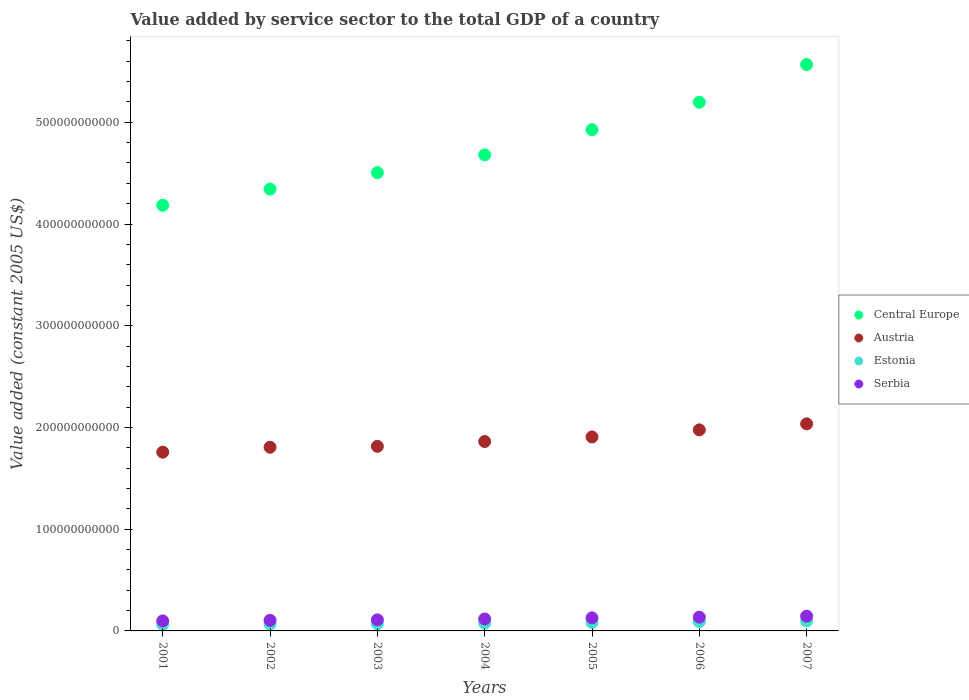How many different coloured dotlines are there?
Give a very brief answer. 4. What is the value added by service sector in Austria in 2006?
Keep it short and to the point. 1.98e+11. Across all years, what is the maximum value added by service sector in Serbia?
Keep it short and to the point. 1.45e+1. Across all years, what is the minimum value added by service sector in Estonia?
Give a very brief answer. 6.33e+09. What is the total value added by service sector in Central Europe in the graph?
Give a very brief answer. 3.34e+12. What is the difference between the value added by service sector in Estonia in 2001 and that in 2006?
Your response must be concise. -2.82e+09. What is the difference between the value added by service sector in Serbia in 2002 and the value added by service sector in Central Europe in 2007?
Provide a succinct answer. -5.46e+11. What is the average value added by service sector in Estonia per year?
Provide a short and direct response. 7.84e+09. In the year 2004, what is the difference between the value added by service sector in Serbia and value added by service sector in Estonia?
Provide a short and direct response. 4.15e+09. In how many years, is the value added by service sector in Serbia greater than 400000000000 US$?
Ensure brevity in your answer.  0. What is the ratio of the value added by service sector in Estonia in 2005 to that in 2007?
Provide a succinct answer. 0.85. Is the value added by service sector in Central Europe in 2004 less than that in 2007?
Offer a terse response. Yes. What is the difference between the highest and the second highest value added by service sector in Austria?
Your answer should be compact. 5.94e+09. What is the difference between the highest and the lowest value added by service sector in Austria?
Provide a short and direct response. 2.78e+1. Is it the case that in every year, the sum of the value added by service sector in Austria and value added by service sector in Serbia  is greater than the sum of value added by service sector in Central Europe and value added by service sector in Estonia?
Offer a terse response. Yes. How many dotlines are there?
Your answer should be compact. 4. What is the difference between two consecutive major ticks on the Y-axis?
Ensure brevity in your answer.  1.00e+11. Does the graph contain any zero values?
Give a very brief answer. No. Does the graph contain grids?
Your answer should be compact. No. Where does the legend appear in the graph?
Provide a succinct answer. Center right. How are the legend labels stacked?
Provide a succinct answer. Vertical. What is the title of the graph?
Offer a terse response. Value added by service sector to the total GDP of a country. Does "Bolivia" appear as one of the legend labels in the graph?
Provide a succinct answer. No. What is the label or title of the X-axis?
Your answer should be very brief. Years. What is the label or title of the Y-axis?
Give a very brief answer. Value added (constant 2005 US$). What is the Value added (constant 2005 US$) of Central Europe in 2001?
Keep it short and to the point. 4.18e+11. What is the Value added (constant 2005 US$) in Austria in 2001?
Your answer should be compact. 1.76e+11. What is the Value added (constant 2005 US$) in Estonia in 2001?
Provide a short and direct response. 6.33e+09. What is the Value added (constant 2005 US$) of Serbia in 2001?
Your answer should be very brief. 9.84e+09. What is the Value added (constant 2005 US$) of Central Europe in 2002?
Your answer should be compact. 4.34e+11. What is the Value added (constant 2005 US$) in Austria in 2002?
Provide a succinct answer. 1.81e+11. What is the Value added (constant 2005 US$) of Estonia in 2002?
Ensure brevity in your answer.  6.65e+09. What is the Value added (constant 2005 US$) of Serbia in 2002?
Offer a terse response. 1.04e+1. What is the Value added (constant 2005 US$) of Central Europe in 2003?
Provide a short and direct response. 4.50e+11. What is the Value added (constant 2005 US$) in Austria in 2003?
Your answer should be very brief. 1.81e+11. What is the Value added (constant 2005 US$) of Estonia in 2003?
Offer a terse response. 7.11e+09. What is the Value added (constant 2005 US$) in Serbia in 2003?
Your response must be concise. 1.09e+1. What is the Value added (constant 2005 US$) in Central Europe in 2004?
Make the answer very short. 4.68e+11. What is the Value added (constant 2005 US$) in Austria in 2004?
Offer a very short reply. 1.86e+11. What is the Value added (constant 2005 US$) in Estonia in 2004?
Offer a terse response. 7.62e+09. What is the Value added (constant 2005 US$) in Serbia in 2004?
Your answer should be very brief. 1.18e+1. What is the Value added (constant 2005 US$) in Central Europe in 2005?
Provide a short and direct response. 4.93e+11. What is the Value added (constant 2005 US$) of Austria in 2005?
Make the answer very short. 1.91e+11. What is the Value added (constant 2005 US$) in Estonia in 2005?
Make the answer very short. 8.28e+09. What is the Value added (constant 2005 US$) in Serbia in 2005?
Your answer should be compact. 1.29e+1. What is the Value added (constant 2005 US$) of Central Europe in 2006?
Your answer should be compact. 5.20e+11. What is the Value added (constant 2005 US$) in Austria in 2006?
Your answer should be very brief. 1.98e+11. What is the Value added (constant 2005 US$) in Estonia in 2006?
Give a very brief answer. 9.14e+09. What is the Value added (constant 2005 US$) of Serbia in 2006?
Provide a succinct answer. 1.35e+1. What is the Value added (constant 2005 US$) of Central Europe in 2007?
Your answer should be compact. 5.57e+11. What is the Value added (constant 2005 US$) in Austria in 2007?
Ensure brevity in your answer.  2.04e+11. What is the Value added (constant 2005 US$) of Estonia in 2007?
Keep it short and to the point. 9.79e+09. What is the Value added (constant 2005 US$) in Serbia in 2007?
Your answer should be very brief. 1.45e+1. Across all years, what is the maximum Value added (constant 2005 US$) in Central Europe?
Offer a very short reply. 5.57e+11. Across all years, what is the maximum Value added (constant 2005 US$) in Austria?
Offer a very short reply. 2.04e+11. Across all years, what is the maximum Value added (constant 2005 US$) of Estonia?
Make the answer very short. 9.79e+09. Across all years, what is the maximum Value added (constant 2005 US$) of Serbia?
Your answer should be compact. 1.45e+1. Across all years, what is the minimum Value added (constant 2005 US$) of Central Europe?
Make the answer very short. 4.18e+11. Across all years, what is the minimum Value added (constant 2005 US$) in Austria?
Your response must be concise. 1.76e+11. Across all years, what is the minimum Value added (constant 2005 US$) of Estonia?
Your answer should be very brief. 6.33e+09. Across all years, what is the minimum Value added (constant 2005 US$) of Serbia?
Keep it short and to the point. 9.84e+09. What is the total Value added (constant 2005 US$) of Central Europe in the graph?
Ensure brevity in your answer.  3.34e+12. What is the total Value added (constant 2005 US$) of Austria in the graph?
Provide a short and direct response. 1.32e+12. What is the total Value added (constant 2005 US$) in Estonia in the graph?
Give a very brief answer. 5.49e+1. What is the total Value added (constant 2005 US$) in Serbia in the graph?
Provide a short and direct response. 8.38e+1. What is the difference between the Value added (constant 2005 US$) of Central Europe in 2001 and that in 2002?
Give a very brief answer. -1.59e+1. What is the difference between the Value added (constant 2005 US$) in Austria in 2001 and that in 2002?
Your answer should be very brief. -4.82e+09. What is the difference between the Value added (constant 2005 US$) of Estonia in 2001 and that in 2002?
Provide a short and direct response. -3.25e+08. What is the difference between the Value added (constant 2005 US$) of Serbia in 2001 and that in 2002?
Give a very brief answer. -5.59e+08. What is the difference between the Value added (constant 2005 US$) of Central Europe in 2001 and that in 2003?
Keep it short and to the point. -3.21e+1. What is the difference between the Value added (constant 2005 US$) of Austria in 2001 and that in 2003?
Offer a terse response. -5.73e+09. What is the difference between the Value added (constant 2005 US$) of Estonia in 2001 and that in 2003?
Provide a short and direct response. -7.81e+08. What is the difference between the Value added (constant 2005 US$) of Serbia in 2001 and that in 2003?
Your answer should be very brief. -1.05e+09. What is the difference between the Value added (constant 2005 US$) in Central Europe in 2001 and that in 2004?
Your answer should be compact. -4.96e+1. What is the difference between the Value added (constant 2005 US$) in Austria in 2001 and that in 2004?
Your answer should be compact. -1.05e+1. What is the difference between the Value added (constant 2005 US$) in Estonia in 2001 and that in 2004?
Your response must be concise. -1.29e+09. What is the difference between the Value added (constant 2005 US$) in Serbia in 2001 and that in 2004?
Your answer should be compact. -1.93e+09. What is the difference between the Value added (constant 2005 US$) in Central Europe in 2001 and that in 2005?
Offer a very short reply. -7.43e+1. What is the difference between the Value added (constant 2005 US$) of Austria in 2001 and that in 2005?
Your answer should be compact. -1.50e+1. What is the difference between the Value added (constant 2005 US$) of Estonia in 2001 and that in 2005?
Make the answer very short. -1.95e+09. What is the difference between the Value added (constant 2005 US$) of Serbia in 2001 and that in 2005?
Your response must be concise. -3.02e+09. What is the difference between the Value added (constant 2005 US$) of Central Europe in 2001 and that in 2006?
Make the answer very short. -1.01e+11. What is the difference between the Value added (constant 2005 US$) of Austria in 2001 and that in 2006?
Your answer should be very brief. -2.19e+1. What is the difference between the Value added (constant 2005 US$) in Estonia in 2001 and that in 2006?
Offer a terse response. -2.82e+09. What is the difference between the Value added (constant 2005 US$) in Serbia in 2001 and that in 2006?
Make the answer very short. -3.66e+09. What is the difference between the Value added (constant 2005 US$) of Central Europe in 2001 and that in 2007?
Ensure brevity in your answer.  -1.38e+11. What is the difference between the Value added (constant 2005 US$) of Austria in 2001 and that in 2007?
Offer a very short reply. -2.78e+1. What is the difference between the Value added (constant 2005 US$) in Estonia in 2001 and that in 2007?
Offer a very short reply. -3.46e+09. What is the difference between the Value added (constant 2005 US$) in Serbia in 2001 and that in 2007?
Provide a succinct answer. -4.68e+09. What is the difference between the Value added (constant 2005 US$) of Central Europe in 2002 and that in 2003?
Provide a short and direct response. -1.62e+1. What is the difference between the Value added (constant 2005 US$) in Austria in 2002 and that in 2003?
Make the answer very short. -9.14e+08. What is the difference between the Value added (constant 2005 US$) of Estonia in 2002 and that in 2003?
Keep it short and to the point. -4.56e+08. What is the difference between the Value added (constant 2005 US$) in Serbia in 2002 and that in 2003?
Provide a succinct answer. -4.90e+08. What is the difference between the Value added (constant 2005 US$) of Central Europe in 2002 and that in 2004?
Offer a very short reply. -3.37e+1. What is the difference between the Value added (constant 2005 US$) in Austria in 2002 and that in 2004?
Offer a very short reply. -5.64e+09. What is the difference between the Value added (constant 2005 US$) of Estonia in 2002 and that in 2004?
Your answer should be compact. -9.63e+08. What is the difference between the Value added (constant 2005 US$) of Serbia in 2002 and that in 2004?
Provide a short and direct response. -1.37e+09. What is the difference between the Value added (constant 2005 US$) in Central Europe in 2002 and that in 2005?
Your answer should be compact. -5.84e+1. What is the difference between the Value added (constant 2005 US$) of Austria in 2002 and that in 2005?
Keep it short and to the point. -1.01e+1. What is the difference between the Value added (constant 2005 US$) of Estonia in 2002 and that in 2005?
Make the answer very short. -1.62e+09. What is the difference between the Value added (constant 2005 US$) of Serbia in 2002 and that in 2005?
Your response must be concise. -2.46e+09. What is the difference between the Value added (constant 2005 US$) of Central Europe in 2002 and that in 2006?
Provide a succinct answer. -8.54e+1. What is the difference between the Value added (constant 2005 US$) in Austria in 2002 and that in 2006?
Provide a short and direct response. -1.71e+1. What is the difference between the Value added (constant 2005 US$) of Estonia in 2002 and that in 2006?
Offer a terse response. -2.49e+09. What is the difference between the Value added (constant 2005 US$) of Serbia in 2002 and that in 2006?
Ensure brevity in your answer.  -3.11e+09. What is the difference between the Value added (constant 2005 US$) in Central Europe in 2002 and that in 2007?
Your answer should be compact. -1.22e+11. What is the difference between the Value added (constant 2005 US$) of Austria in 2002 and that in 2007?
Keep it short and to the point. -2.30e+1. What is the difference between the Value added (constant 2005 US$) of Estonia in 2002 and that in 2007?
Offer a very short reply. -3.13e+09. What is the difference between the Value added (constant 2005 US$) of Serbia in 2002 and that in 2007?
Your answer should be very brief. -4.13e+09. What is the difference between the Value added (constant 2005 US$) of Central Europe in 2003 and that in 2004?
Offer a very short reply. -1.75e+1. What is the difference between the Value added (constant 2005 US$) in Austria in 2003 and that in 2004?
Make the answer very short. -4.73e+09. What is the difference between the Value added (constant 2005 US$) in Estonia in 2003 and that in 2004?
Ensure brevity in your answer.  -5.08e+08. What is the difference between the Value added (constant 2005 US$) of Serbia in 2003 and that in 2004?
Your answer should be very brief. -8.79e+08. What is the difference between the Value added (constant 2005 US$) in Central Europe in 2003 and that in 2005?
Make the answer very short. -4.22e+1. What is the difference between the Value added (constant 2005 US$) in Austria in 2003 and that in 2005?
Ensure brevity in your answer.  -9.23e+09. What is the difference between the Value added (constant 2005 US$) in Estonia in 2003 and that in 2005?
Give a very brief answer. -1.17e+09. What is the difference between the Value added (constant 2005 US$) in Serbia in 2003 and that in 2005?
Keep it short and to the point. -1.97e+09. What is the difference between the Value added (constant 2005 US$) in Central Europe in 2003 and that in 2006?
Make the answer very short. -6.92e+1. What is the difference between the Value added (constant 2005 US$) in Austria in 2003 and that in 2006?
Offer a very short reply. -1.62e+1. What is the difference between the Value added (constant 2005 US$) of Estonia in 2003 and that in 2006?
Your answer should be very brief. -2.03e+09. What is the difference between the Value added (constant 2005 US$) in Serbia in 2003 and that in 2006?
Ensure brevity in your answer.  -2.61e+09. What is the difference between the Value added (constant 2005 US$) in Central Europe in 2003 and that in 2007?
Your response must be concise. -1.06e+11. What is the difference between the Value added (constant 2005 US$) of Austria in 2003 and that in 2007?
Provide a short and direct response. -2.21e+1. What is the difference between the Value added (constant 2005 US$) of Estonia in 2003 and that in 2007?
Your answer should be very brief. -2.68e+09. What is the difference between the Value added (constant 2005 US$) of Serbia in 2003 and that in 2007?
Provide a short and direct response. -3.64e+09. What is the difference between the Value added (constant 2005 US$) in Central Europe in 2004 and that in 2005?
Keep it short and to the point. -2.47e+1. What is the difference between the Value added (constant 2005 US$) in Austria in 2004 and that in 2005?
Your response must be concise. -4.50e+09. What is the difference between the Value added (constant 2005 US$) in Estonia in 2004 and that in 2005?
Offer a very short reply. -6.59e+08. What is the difference between the Value added (constant 2005 US$) in Serbia in 2004 and that in 2005?
Keep it short and to the point. -1.10e+09. What is the difference between the Value added (constant 2005 US$) of Central Europe in 2004 and that in 2006?
Offer a very short reply. -5.17e+1. What is the difference between the Value added (constant 2005 US$) of Austria in 2004 and that in 2006?
Your answer should be very brief. -1.14e+1. What is the difference between the Value added (constant 2005 US$) in Estonia in 2004 and that in 2006?
Offer a very short reply. -1.53e+09. What is the difference between the Value added (constant 2005 US$) in Serbia in 2004 and that in 2006?
Ensure brevity in your answer.  -1.74e+09. What is the difference between the Value added (constant 2005 US$) of Central Europe in 2004 and that in 2007?
Your answer should be very brief. -8.88e+1. What is the difference between the Value added (constant 2005 US$) in Austria in 2004 and that in 2007?
Give a very brief answer. -1.74e+1. What is the difference between the Value added (constant 2005 US$) of Estonia in 2004 and that in 2007?
Provide a succinct answer. -2.17e+09. What is the difference between the Value added (constant 2005 US$) of Serbia in 2004 and that in 2007?
Provide a short and direct response. -2.76e+09. What is the difference between the Value added (constant 2005 US$) of Central Europe in 2005 and that in 2006?
Offer a very short reply. -2.70e+1. What is the difference between the Value added (constant 2005 US$) of Austria in 2005 and that in 2006?
Your response must be concise. -6.94e+09. What is the difference between the Value added (constant 2005 US$) of Estonia in 2005 and that in 2006?
Offer a very short reply. -8.69e+08. What is the difference between the Value added (constant 2005 US$) in Serbia in 2005 and that in 2006?
Give a very brief answer. -6.40e+08. What is the difference between the Value added (constant 2005 US$) in Central Europe in 2005 and that in 2007?
Provide a succinct answer. -6.40e+1. What is the difference between the Value added (constant 2005 US$) in Austria in 2005 and that in 2007?
Make the answer very short. -1.29e+1. What is the difference between the Value added (constant 2005 US$) in Estonia in 2005 and that in 2007?
Your response must be concise. -1.51e+09. What is the difference between the Value added (constant 2005 US$) in Serbia in 2005 and that in 2007?
Provide a succinct answer. -1.66e+09. What is the difference between the Value added (constant 2005 US$) in Central Europe in 2006 and that in 2007?
Ensure brevity in your answer.  -3.70e+1. What is the difference between the Value added (constant 2005 US$) in Austria in 2006 and that in 2007?
Offer a very short reply. -5.94e+09. What is the difference between the Value added (constant 2005 US$) of Estonia in 2006 and that in 2007?
Your answer should be very brief. -6.43e+08. What is the difference between the Value added (constant 2005 US$) in Serbia in 2006 and that in 2007?
Ensure brevity in your answer.  -1.02e+09. What is the difference between the Value added (constant 2005 US$) in Central Europe in 2001 and the Value added (constant 2005 US$) in Austria in 2002?
Offer a very short reply. 2.38e+11. What is the difference between the Value added (constant 2005 US$) in Central Europe in 2001 and the Value added (constant 2005 US$) in Estonia in 2002?
Your answer should be compact. 4.12e+11. What is the difference between the Value added (constant 2005 US$) of Central Europe in 2001 and the Value added (constant 2005 US$) of Serbia in 2002?
Your response must be concise. 4.08e+11. What is the difference between the Value added (constant 2005 US$) in Austria in 2001 and the Value added (constant 2005 US$) in Estonia in 2002?
Your response must be concise. 1.69e+11. What is the difference between the Value added (constant 2005 US$) of Austria in 2001 and the Value added (constant 2005 US$) of Serbia in 2002?
Provide a short and direct response. 1.65e+11. What is the difference between the Value added (constant 2005 US$) in Estonia in 2001 and the Value added (constant 2005 US$) in Serbia in 2002?
Your answer should be very brief. -4.07e+09. What is the difference between the Value added (constant 2005 US$) of Central Europe in 2001 and the Value added (constant 2005 US$) of Austria in 2003?
Offer a very short reply. 2.37e+11. What is the difference between the Value added (constant 2005 US$) in Central Europe in 2001 and the Value added (constant 2005 US$) in Estonia in 2003?
Your response must be concise. 4.11e+11. What is the difference between the Value added (constant 2005 US$) of Central Europe in 2001 and the Value added (constant 2005 US$) of Serbia in 2003?
Provide a succinct answer. 4.08e+11. What is the difference between the Value added (constant 2005 US$) of Austria in 2001 and the Value added (constant 2005 US$) of Estonia in 2003?
Provide a succinct answer. 1.69e+11. What is the difference between the Value added (constant 2005 US$) of Austria in 2001 and the Value added (constant 2005 US$) of Serbia in 2003?
Keep it short and to the point. 1.65e+11. What is the difference between the Value added (constant 2005 US$) in Estonia in 2001 and the Value added (constant 2005 US$) in Serbia in 2003?
Offer a terse response. -4.56e+09. What is the difference between the Value added (constant 2005 US$) of Central Europe in 2001 and the Value added (constant 2005 US$) of Austria in 2004?
Give a very brief answer. 2.32e+11. What is the difference between the Value added (constant 2005 US$) in Central Europe in 2001 and the Value added (constant 2005 US$) in Estonia in 2004?
Offer a terse response. 4.11e+11. What is the difference between the Value added (constant 2005 US$) in Central Europe in 2001 and the Value added (constant 2005 US$) in Serbia in 2004?
Your response must be concise. 4.07e+11. What is the difference between the Value added (constant 2005 US$) in Austria in 2001 and the Value added (constant 2005 US$) in Estonia in 2004?
Your answer should be very brief. 1.68e+11. What is the difference between the Value added (constant 2005 US$) of Austria in 2001 and the Value added (constant 2005 US$) of Serbia in 2004?
Ensure brevity in your answer.  1.64e+11. What is the difference between the Value added (constant 2005 US$) of Estonia in 2001 and the Value added (constant 2005 US$) of Serbia in 2004?
Provide a succinct answer. -5.44e+09. What is the difference between the Value added (constant 2005 US$) in Central Europe in 2001 and the Value added (constant 2005 US$) in Austria in 2005?
Offer a terse response. 2.28e+11. What is the difference between the Value added (constant 2005 US$) in Central Europe in 2001 and the Value added (constant 2005 US$) in Estonia in 2005?
Your response must be concise. 4.10e+11. What is the difference between the Value added (constant 2005 US$) of Central Europe in 2001 and the Value added (constant 2005 US$) of Serbia in 2005?
Your response must be concise. 4.06e+11. What is the difference between the Value added (constant 2005 US$) of Austria in 2001 and the Value added (constant 2005 US$) of Estonia in 2005?
Your response must be concise. 1.67e+11. What is the difference between the Value added (constant 2005 US$) in Austria in 2001 and the Value added (constant 2005 US$) in Serbia in 2005?
Provide a succinct answer. 1.63e+11. What is the difference between the Value added (constant 2005 US$) in Estonia in 2001 and the Value added (constant 2005 US$) in Serbia in 2005?
Make the answer very short. -6.54e+09. What is the difference between the Value added (constant 2005 US$) in Central Europe in 2001 and the Value added (constant 2005 US$) in Austria in 2006?
Offer a very short reply. 2.21e+11. What is the difference between the Value added (constant 2005 US$) in Central Europe in 2001 and the Value added (constant 2005 US$) in Estonia in 2006?
Your answer should be very brief. 4.09e+11. What is the difference between the Value added (constant 2005 US$) in Central Europe in 2001 and the Value added (constant 2005 US$) in Serbia in 2006?
Offer a terse response. 4.05e+11. What is the difference between the Value added (constant 2005 US$) in Austria in 2001 and the Value added (constant 2005 US$) in Estonia in 2006?
Your answer should be very brief. 1.67e+11. What is the difference between the Value added (constant 2005 US$) of Austria in 2001 and the Value added (constant 2005 US$) of Serbia in 2006?
Keep it short and to the point. 1.62e+11. What is the difference between the Value added (constant 2005 US$) in Estonia in 2001 and the Value added (constant 2005 US$) in Serbia in 2006?
Offer a very short reply. -7.18e+09. What is the difference between the Value added (constant 2005 US$) in Central Europe in 2001 and the Value added (constant 2005 US$) in Austria in 2007?
Provide a succinct answer. 2.15e+11. What is the difference between the Value added (constant 2005 US$) of Central Europe in 2001 and the Value added (constant 2005 US$) of Estonia in 2007?
Your response must be concise. 4.09e+11. What is the difference between the Value added (constant 2005 US$) in Central Europe in 2001 and the Value added (constant 2005 US$) in Serbia in 2007?
Offer a very short reply. 4.04e+11. What is the difference between the Value added (constant 2005 US$) in Austria in 2001 and the Value added (constant 2005 US$) in Estonia in 2007?
Keep it short and to the point. 1.66e+11. What is the difference between the Value added (constant 2005 US$) of Austria in 2001 and the Value added (constant 2005 US$) of Serbia in 2007?
Make the answer very short. 1.61e+11. What is the difference between the Value added (constant 2005 US$) in Estonia in 2001 and the Value added (constant 2005 US$) in Serbia in 2007?
Your answer should be compact. -8.20e+09. What is the difference between the Value added (constant 2005 US$) in Central Europe in 2002 and the Value added (constant 2005 US$) in Austria in 2003?
Make the answer very short. 2.53e+11. What is the difference between the Value added (constant 2005 US$) in Central Europe in 2002 and the Value added (constant 2005 US$) in Estonia in 2003?
Make the answer very short. 4.27e+11. What is the difference between the Value added (constant 2005 US$) in Central Europe in 2002 and the Value added (constant 2005 US$) in Serbia in 2003?
Offer a very short reply. 4.23e+11. What is the difference between the Value added (constant 2005 US$) of Austria in 2002 and the Value added (constant 2005 US$) of Estonia in 2003?
Make the answer very short. 1.73e+11. What is the difference between the Value added (constant 2005 US$) of Austria in 2002 and the Value added (constant 2005 US$) of Serbia in 2003?
Offer a very short reply. 1.70e+11. What is the difference between the Value added (constant 2005 US$) in Estonia in 2002 and the Value added (constant 2005 US$) in Serbia in 2003?
Make the answer very short. -4.24e+09. What is the difference between the Value added (constant 2005 US$) in Central Europe in 2002 and the Value added (constant 2005 US$) in Austria in 2004?
Make the answer very short. 2.48e+11. What is the difference between the Value added (constant 2005 US$) of Central Europe in 2002 and the Value added (constant 2005 US$) of Estonia in 2004?
Provide a succinct answer. 4.27e+11. What is the difference between the Value added (constant 2005 US$) in Central Europe in 2002 and the Value added (constant 2005 US$) in Serbia in 2004?
Your answer should be compact. 4.23e+11. What is the difference between the Value added (constant 2005 US$) of Austria in 2002 and the Value added (constant 2005 US$) of Estonia in 2004?
Your answer should be very brief. 1.73e+11. What is the difference between the Value added (constant 2005 US$) of Austria in 2002 and the Value added (constant 2005 US$) of Serbia in 2004?
Make the answer very short. 1.69e+11. What is the difference between the Value added (constant 2005 US$) in Estonia in 2002 and the Value added (constant 2005 US$) in Serbia in 2004?
Your answer should be compact. -5.12e+09. What is the difference between the Value added (constant 2005 US$) in Central Europe in 2002 and the Value added (constant 2005 US$) in Austria in 2005?
Provide a succinct answer. 2.44e+11. What is the difference between the Value added (constant 2005 US$) in Central Europe in 2002 and the Value added (constant 2005 US$) in Estonia in 2005?
Provide a short and direct response. 4.26e+11. What is the difference between the Value added (constant 2005 US$) of Central Europe in 2002 and the Value added (constant 2005 US$) of Serbia in 2005?
Ensure brevity in your answer.  4.21e+11. What is the difference between the Value added (constant 2005 US$) of Austria in 2002 and the Value added (constant 2005 US$) of Estonia in 2005?
Make the answer very short. 1.72e+11. What is the difference between the Value added (constant 2005 US$) of Austria in 2002 and the Value added (constant 2005 US$) of Serbia in 2005?
Offer a terse response. 1.68e+11. What is the difference between the Value added (constant 2005 US$) in Estonia in 2002 and the Value added (constant 2005 US$) in Serbia in 2005?
Ensure brevity in your answer.  -6.21e+09. What is the difference between the Value added (constant 2005 US$) in Central Europe in 2002 and the Value added (constant 2005 US$) in Austria in 2006?
Keep it short and to the point. 2.37e+11. What is the difference between the Value added (constant 2005 US$) in Central Europe in 2002 and the Value added (constant 2005 US$) in Estonia in 2006?
Your response must be concise. 4.25e+11. What is the difference between the Value added (constant 2005 US$) in Central Europe in 2002 and the Value added (constant 2005 US$) in Serbia in 2006?
Your response must be concise. 4.21e+11. What is the difference between the Value added (constant 2005 US$) in Austria in 2002 and the Value added (constant 2005 US$) in Estonia in 2006?
Provide a succinct answer. 1.71e+11. What is the difference between the Value added (constant 2005 US$) of Austria in 2002 and the Value added (constant 2005 US$) of Serbia in 2006?
Your answer should be compact. 1.67e+11. What is the difference between the Value added (constant 2005 US$) of Estonia in 2002 and the Value added (constant 2005 US$) of Serbia in 2006?
Your answer should be very brief. -6.85e+09. What is the difference between the Value added (constant 2005 US$) of Central Europe in 2002 and the Value added (constant 2005 US$) of Austria in 2007?
Provide a short and direct response. 2.31e+11. What is the difference between the Value added (constant 2005 US$) of Central Europe in 2002 and the Value added (constant 2005 US$) of Estonia in 2007?
Provide a short and direct response. 4.25e+11. What is the difference between the Value added (constant 2005 US$) in Central Europe in 2002 and the Value added (constant 2005 US$) in Serbia in 2007?
Give a very brief answer. 4.20e+11. What is the difference between the Value added (constant 2005 US$) of Austria in 2002 and the Value added (constant 2005 US$) of Estonia in 2007?
Offer a terse response. 1.71e+11. What is the difference between the Value added (constant 2005 US$) of Austria in 2002 and the Value added (constant 2005 US$) of Serbia in 2007?
Make the answer very short. 1.66e+11. What is the difference between the Value added (constant 2005 US$) of Estonia in 2002 and the Value added (constant 2005 US$) of Serbia in 2007?
Give a very brief answer. -7.87e+09. What is the difference between the Value added (constant 2005 US$) of Central Europe in 2003 and the Value added (constant 2005 US$) of Austria in 2004?
Provide a short and direct response. 2.64e+11. What is the difference between the Value added (constant 2005 US$) of Central Europe in 2003 and the Value added (constant 2005 US$) of Estonia in 2004?
Make the answer very short. 4.43e+11. What is the difference between the Value added (constant 2005 US$) in Central Europe in 2003 and the Value added (constant 2005 US$) in Serbia in 2004?
Ensure brevity in your answer.  4.39e+11. What is the difference between the Value added (constant 2005 US$) of Austria in 2003 and the Value added (constant 2005 US$) of Estonia in 2004?
Ensure brevity in your answer.  1.74e+11. What is the difference between the Value added (constant 2005 US$) in Austria in 2003 and the Value added (constant 2005 US$) in Serbia in 2004?
Your answer should be compact. 1.70e+11. What is the difference between the Value added (constant 2005 US$) in Estonia in 2003 and the Value added (constant 2005 US$) in Serbia in 2004?
Your response must be concise. -4.66e+09. What is the difference between the Value added (constant 2005 US$) in Central Europe in 2003 and the Value added (constant 2005 US$) in Austria in 2005?
Ensure brevity in your answer.  2.60e+11. What is the difference between the Value added (constant 2005 US$) of Central Europe in 2003 and the Value added (constant 2005 US$) of Estonia in 2005?
Make the answer very short. 4.42e+11. What is the difference between the Value added (constant 2005 US$) of Central Europe in 2003 and the Value added (constant 2005 US$) of Serbia in 2005?
Provide a short and direct response. 4.38e+11. What is the difference between the Value added (constant 2005 US$) in Austria in 2003 and the Value added (constant 2005 US$) in Estonia in 2005?
Give a very brief answer. 1.73e+11. What is the difference between the Value added (constant 2005 US$) of Austria in 2003 and the Value added (constant 2005 US$) of Serbia in 2005?
Provide a succinct answer. 1.69e+11. What is the difference between the Value added (constant 2005 US$) in Estonia in 2003 and the Value added (constant 2005 US$) in Serbia in 2005?
Your response must be concise. -5.76e+09. What is the difference between the Value added (constant 2005 US$) in Central Europe in 2003 and the Value added (constant 2005 US$) in Austria in 2006?
Ensure brevity in your answer.  2.53e+11. What is the difference between the Value added (constant 2005 US$) of Central Europe in 2003 and the Value added (constant 2005 US$) of Estonia in 2006?
Provide a succinct answer. 4.41e+11. What is the difference between the Value added (constant 2005 US$) of Central Europe in 2003 and the Value added (constant 2005 US$) of Serbia in 2006?
Offer a terse response. 4.37e+11. What is the difference between the Value added (constant 2005 US$) of Austria in 2003 and the Value added (constant 2005 US$) of Estonia in 2006?
Offer a terse response. 1.72e+11. What is the difference between the Value added (constant 2005 US$) in Austria in 2003 and the Value added (constant 2005 US$) in Serbia in 2006?
Ensure brevity in your answer.  1.68e+11. What is the difference between the Value added (constant 2005 US$) in Estonia in 2003 and the Value added (constant 2005 US$) in Serbia in 2006?
Offer a terse response. -6.40e+09. What is the difference between the Value added (constant 2005 US$) of Central Europe in 2003 and the Value added (constant 2005 US$) of Austria in 2007?
Your answer should be very brief. 2.47e+11. What is the difference between the Value added (constant 2005 US$) of Central Europe in 2003 and the Value added (constant 2005 US$) of Estonia in 2007?
Provide a succinct answer. 4.41e+11. What is the difference between the Value added (constant 2005 US$) in Central Europe in 2003 and the Value added (constant 2005 US$) in Serbia in 2007?
Your response must be concise. 4.36e+11. What is the difference between the Value added (constant 2005 US$) of Austria in 2003 and the Value added (constant 2005 US$) of Estonia in 2007?
Your response must be concise. 1.72e+11. What is the difference between the Value added (constant 2005 US$) of Austria in 2003 and the Value added (constant 2005 US$) of Serbia in 2007?
Offer a very short reply. 1.67e+11. What is the difference between the Value added (constant 2005 US$) of Estonia in 2003 and the Value added (constant 2005 US$) of Serbia in 2007?
Offer a terse response. -7.42e+09. What is the difference between the Value added (constant 2005 US$) in Central Europe in 2004 and the Value added (constant 2005 US$) in Austria in 2005?
Offer a terse response. 2.77e+11. What is the difference between the Value added (constant 2005 US$) in Central Europe in 2004 and the Value added (constant 2005 US$) in Estonia in 2005?
Ensure brevity in your answer.  4.60e+11. What is the difference between the Value added (constant 2005 US$) of Central Europe in 2004 and the Value added (constant 2005 US$) of Serbia in 2005?
Offer a terse response. 4.55e+11. What is the difference between the Value added (constant 2005 US$) in Austria in 2004 and the Value added (constant 2005 US$) in Estonia in 2005?
Make the answer very short. 1.78e+11. What is the difference between the Value added (constant 2005 US$) in Austria in 2004 and the Value added (constant 2005 US$) in Serbia in 2005?
Your answer should be very brief. 1.73e+11. What is the difference between the Value added (constant 2005 US$) in Estonia in 2004 and the Value added (constant 2005 US$) in Serbia in 2005?
Ensure brevity in your answer.  -5.25e+09. What is the difference between the Value added (constant 2005 US$) in Central Europe in 2004 and the Value added (constant 2005 US$) in Austria in 2006?
Your answer should be very brief. 2.70e+11. What is the difference between the Value added (constant 2005 US$) in Central Europe in 2004 and the Value added (constant 2005 US$) in Estonia in 2006?
Keep it short and to the point. 4.59e+11. What is the difference between the Value added (constant 2005 US$) in Central Europe in 2004 and the Value added (constant 2005 US$) in Serbia in 2006?
Ensure brevity in your answer.  4.54e+11. What is the difference between the Value added (constant 2005 US$) in Austria in 2004 and the Value added (constant 2005 US$) in Estonia in 2006?
Make the answer very short. 1.77e+11. What is the difference between the Value added (constant 2005 US$) of Austria in 2004 and the Value added (constant 2005 US$) of Serbia in 2006?
Give a very brief answer. 1.73e+11. What is the difference between the Value added (constant 2005 US$) in Estonia in 2004 and the Value added (constant 2005 US$) in Serbia in 2006?
Your answer should be very brief. -5.89e+09. What is the difference between the Value added (constant 2005 US$) of Central Europe in 2004 and the Value added (constant 2005 US$) of Austria in 2007?
Keep it short and to the point. 2.64e+11. What is the difference between the Value added (constant 2005 US$) in Central Europe in 2004 and the Value added (constant 2005 US$) in Estonia in 2007?
Offer a terse response. 4.58e+11. What is the difference between the Value added (constant 2005 US$) in Central Europe in 2004 and the Value added (constant 2005 US$) in Serbia in 2007?
Keep it short and to the point. 4.53e+11. What is the difference between the Value added (constant 2005 US$) of Austria in 2004 and the Value added (constant 2005 US$) of Estonia in 2007?
Your answer should be very brief. 1.76e+11. What is the difference between the Value added (constant 2005 US$) in Austria in 2004 and the Value added (constant 2005 US$) in Serbia in 2007?
Keep it short and to the point. 1.72e+11. What is the difference between the Value added (constant 2005 US$) in Estonia in 2004 and the Value added (constant 2005 US$) in Serbia in 2007?
Give a very brief answer. -6.91e+09. What is the difference between the Value added (constant 2005 US$) in Central Europe in 2005 and the Value added (constant 2005 US$) in Austria in 2006?
Offer a very short reply. 2.95e+11. What is the difference between the Value added (constant 2005 US$) of Central Europe in 2005 and the Value added (constant 2005 US$) of Estonia in 2006?
Give a very brief answer. 4.84e+11. What is the difference between the Value added (constant 2005 US$) in Central Europe in 2005 and the Value added (constant 2005 US$) in Serbia in 2006?
Give a very brief answer. 4.79e+11. What is the difference between the Value added (constant 2005 US$) of Austria in 2005 and the Value added (constant 2005 US$) of Estonia in 2006?
Provide a short and direct response. 1.82e+11. What is the difference between the Value added (constant 2005 US$) of Austria in 2005 and the Value added (constant 2005 US$) of Serbia in 2006?
Your answer should be very brief. 1.77e+11. What is the difference between the Value added (constant 2005 US$) of Estonia in 2005 and the Value added (constant 2005 US$) of Serbia in 2006?
Your response must be concise. -5.23e+09. What is the difference between the Value added (constant 2005 US$) in Central Europe in 2005 and the Value added (constant 2005 US$) in Austria in 2007?
Provide a succinct answer. 2.89e+11. What is the difference between the Value added (constant 2005 US$) in Central Europe in 2005 and the Value added (constant 2005 US$) in Estonia in 2007?
Give a very brief answer. 4.83e+11. What is the difference between the Value added (constant 2005 US$) in Central Europe in 2005 and the Value added (constant 2005 US$) in Serbia in 2007?
Offer a very short reply. 4.78e+11. What is the difference between the Value added (constant 2005 US$) in Austria in 2005 and the Value added (constant 2005 US$) in Estonia in 2007?
Offer a very short reply. 1.81e+11. What is the difference between the Value added (constant 2005 US$) of Austria in 2005 and the Value added (constant 2005 US$) of Serbia in 2007?
Keep it short and to the point. 1.76e+11. What is the difference between the Value added (constant 2005 US$) in Estonia in 2005 and the Value added (constant 2005 US$) in Serbia in 2007?
Keep it short and to the point. -6.25e+09. What is the difference between the Value added (constant 2005 US$) of Central Europe in 2006 and the Value added (constant 2005 US$) of Austria in 2007?
Provide a short and direct response. 3.16e+11. What is the difference between the Value added (constant 2005 US$) in Central Europe in 2006 and the Value added (constant 2005 US$) in Estonia in 2007?
Make the answer very short. 5.10e+11. What is the difference between the Value added (constant 2005 US$) in Central Europe in 2006 and the Value added (constant 2005 US$) in Serbia in 2007?
Provide a succinct answer. 5.05e+11. What is the difference between the Value added (constant 2005 US$) of Austria in 2006 and the Value added (constant 2005 US$) of Estonia in 2007?
Offer a very short reply. 1.88e+11. What is the difference between the Value added (constant 2005 US$) of Austria in 2006 and the Value added (constant 2005 US$) of Serbia in 2007?
Provide a succinct answer. 1.83e+11. What is the difference between the Value added (constant 2005 US$) of Estonia in 2006 and the Value added (constant 2005 US$) of Serbia in 2007?
Ensure brevity in your answer.  -5.38e+09. What is the average Value added (constant 2005 US$) in Central Europe per year?
Provide a succinct answer. 4.77e+11. What is the average Value added (constant 2005 US$) of Austria per year?
Keep it short and to the point. 1.88e+11. What is the average Value added (constant 2005 US$) in Estonia per year?
Make the answer very short. 7.84e+09. What is the average Value added (constant 2005 US$) of Serbia per year?
Give a very brief answer. 1.20e+1. In the year 2001, what is the difference between the Value added (constant 2005 US$) in Central Europe and Value added (constant 2005 US$) in Austria?
Your answer should be very brief. 2.43e+11. In the year 2001, what is the difference between the Value added (constant 2005 US$) in Central Europe and Value added (constant 2005 US$) in Estonia?
Keep it short and to the point. 4.12e+11. In the year 2001, what is the difference between the Value added (constant 2005 US$) of Central Europe and Value added (constant 2005 US$) of Serbia?
Keep it short and to the point. 4.09e+11. In the year 2001, what is the difference between the Value added (constant 2005 US$) of Austria and Value added (constant 2005 US$) of Estonia?
Give a very brief answer. 1.69e+11. In the year 2001, what is the difference between the Value added (constant 2005 US$) of Austria and Value added (constant 2005 US$) of Serbia?
Your answer should be compact. 1.66e+11. In the year 2001, what is the difference between the Value added (constant 2005 US$) of Estonia and Value added (constant 2005 US$) of Serbia?
Your response must be concise. -3.51e+09. In the year 2002, what is the difference between the Value added (constant 2005 US$) of Central Europe and Value added (constant 2005 US$) of Austria?
Offer a terse response. 2.54e+11. In the year 2002, what is the difference between the Value added (constant 2005 US$) in Central Europe and Value added (constant 2005 US$) in Estonia?
Make the answer very short. 4.28e+11. In the year 2002, what is the difference between the Value added (constant 2005 US$) of Central Europe and Value added (constant 2005 US$) of Serbia?
Make the answer very short. 4.24e+11. In the year 2002, what is the difference between the Value added (constant 2005 US$) in Austria and Value added (constant 2005 US$) in Estonia?
Keep it short and to the point. 1.74e+11. In the year 2002, what is the difference between the Value added (constant 2005 US$) of Austria and Value added (constant 2005 US$) of Serbia?
Make the answer very short. 1.70e+11. In the year 2002, what is the difference between the Value added (constant 2005 US$) of Estonia and Value added (constant 2005 US$) of Serbia?
Offer a very short reply. -3.75e+09. In the year 2003, what is the difference between the Value added (constant 2005 US$) in Central Europe and Value added (constant 2005 US$) in Austria?
Give a very brief answer. 2.69e+11. In the year 2003, what is the difference between the Value added (constant 2005 US$) in Central Europe and Value added (constant 2005 US$) in Estonia?
Your answer should be compact. 4.43e+11. In the year 2003, what is the difference between the Value added (constant 2005 US$) of Central Europe and Value added (constant 2005 US$) of Serbia?
Your response must be concise. 4.40e+11. In the year 2003, what is the difference between the Value added (constant 2005 US$) in Austria and Value added (constant 2005 US$) in Estonia?
Offer a terse response. 1.74e+11. In the year 2003, what is the difference between the Value added (constant 2005 US$) in Austria and Value added (constant 2005 US$) in Serbia?
Provide a short and direct response. 1.71e+11. In the year 2003, what is the difference between the Value added (constant 2005 US$) in Estonia and Value added (constant 2005 US$) in Serbia?
Ensure brevity in your answer.  -3.78e+09. In the year 2004, what is the difference between the Value added (constant 2005 US$) of Central Europe and Value added (constant 2005 US$) of Austria?
Keep it short and to the point. 2.82e+11. In the year 2004, what is the difference between the Value added (constant 2005 US$) in Central Europe and Value added (constant 2005 US$) in Estonia?
Provide a succinct answer. 4.60e+11. In the year 2004, what is the difference between the Value added (constant 2005 US$) in Central Europe and Value added (constant 2005 US$) in Serbia?
Give a very brief answer. 4.56e+11. In the year 2004, what is the difference between the Value added (constant 2005 US$) in Austria and Value added (constant 2005 US$) in Estonia?
Keep it short and to the point. 1.79e+11. In the year 2004, what is the difference between the Value added (constant 2005 US$) in Austria and Value added (constant 2005 US$) in Serbia?
Your answer should be compact. 1.74e+11. In the year 2004, what is the difference between the Value added (constant 2005 US$) in Estonia and Value added (constant 2005 US$) in Serbia?
Your response must be concise. -4.15e+09. In the year 2005, what is the difference between the Value added (constant 2005 US$) of Central Europe and Value added (constant 2005 US$) of Austria?
Make the answer very short. 3.02e+11. In the year 2005, what is the difference between the Value added (constant 2005 US$) of Central Europe and Value added (constant 2005 US$) of Estonia?
Ensure brevity in your answer.  4.84e+11. In the year 2005, what is the difference between the Value added (constant 2005 US$) in Central Europe and Value added (constant 2005 US$) in Serbia?
Your answer should be compact. 4.80e+11. In the year 2005, what is the difference between the Value added (constant 2005 US$) in Austria and Value added (constant 2005 US$) in Estonia?
Your response must be concise. 1.82e+11. In the year 2005, what is the difference between the Value added (constant 2005 US$) of Austria and Value added (constant 2005 US$) of Serbia?
Give a very brief answer. 1.78e+11. In the year 2005, what is the difference between the Value added (constant 2005 US$) in Estonia and Value added (constant 2005 US$) in Serbia?
Make the answer very short. -4.59e+09. In the year 2006, what is the difference between the Value added (constant 2005 US$) of Central Europe and Value added (constant 2005 US$) of Austria?
Make the answer very short. 3.22e+11. In the year 2006, what is the difference between the Value added (constant 2005 US$) of Central Europe and Value added (constant 2005 US$) of Estonia?
Provide a succinct answer. 5.11e+11. In the year 2006, what is the difference between the Value added (constant 2005 US$) in Central Europe and Value added (constant 2005 US$) in Serbia?
Ensure brevity in your answer.  5.06e+11. In the year 2006, what is the difference between the Value added (constant 2005 US$) of Austria and Value added (constant 2005 US$) of Estonia?
Offer a very short reply. 1.88e+11. In the year 2006, what is the difference between the Value added (constant 2005 US$) of Austria and Value added (constant 2005 US$) of Serbia?
Keep it short and to the point. 1.84e+11. In the year 2006, what is the difference between the Value added (constant 2005 US$) in Estonia and Value added (constant 2005 US$) in Serbia?
Your answer should be compact. -4.36e+09. In the year 2007, what is the difference between the Value added (constant 2005 US$) of Central Europe and Value added (constant 2005 US$) of Austria?
Keep it short and to the point. 3.53e+11. In the year 2007, what is the difference between the Value added (constant 2005 US$) of Central Europe and Value added (constant 2005 US$) of Estonia?
Your response must be concise. 5.47e+11. In the year 2007, what is the difference between the Value added (constant 2005 US$) of Central Europe and Value added (constant 2005 US$) of Serbia?
Give a very brief answer. 5.42e+11. In the year 2007, what is the difference between the Value added (constant 2005 US$) of Austria and Value added (constant 2005 US$) of Estonia?
Keep it short and to the point. 1.94e+11. In the year 2007, what is the difference between the Value added (constant 2005 US$) of Austria and Value added (constant 2005 US$) of Serbia?
Provide a short and direct response. 1.89e+11. In the year 2007, what is the difference between the Value added (constant 2005 US$) in Estonia and Value added (constant 2005 US$) in Serbia?
Your answer should be compact. -4.74e+09. What is the ratio of the Value added (constant 2005 US$) of Central Europe in 2001 to that in 2002?
Ensure brevity in your answer.  0.96. What is the ratio of the Value added (constant 2005 US$) of Austria in 2001 to that in 2002?
Provide a short and direct response. 0.97. What is the ratio of the Value added (constant 2005 US$) in Estonia in 2001 to that in 2002?
Your response must be concise. 0.95. What is the ratio of the Value added (constant 2005 US$) of Serbia in 2001 to that in 2002?
Your answer should be compact. 0.95. What is the ratio of the Value added (constant 2005 US$) of Central Europe in 2001 to that in 2003?
Your answer should be very brief. 0.93. What is the ratio of the Value added (constant 2005 US$) in Austria in 2001 to that in 2003?
Provide a short and direct response. 0.97. What is the ratio of the Value added (constant 2005 US$) in Estonia in 2001 to that in 2003?
Your answer should be very brief. 0.89. What is the ratio of the Value added (constant 2005 US$) of Serbia in 2001 to that in 2003?
Your answer should be very brief. 0.9. What is the ratio of the Value added (constant 2005 US$) of Central Europe in 2001 to that in 2004?
Ensure brevity in your answer.  0.89. What is the ratio of the Value added (constant 2005 US$) in Austria in 2001 to that in 2004?
Make the answer very short. 0.94. What is the ratio of the Value added (constant 2005 US$) of Estonia in 2001 to that in 2004?
Provide a short and direct response. 0.83. What is the ratio of the Value added (constant 2005 US$) in Serbia in 2001 to that in 2004?
Offer a very short reply. 0.84. What is the ratio of the Value added (constant 2005 US$) in Central Europe in 2001 to that in 2005?
Provide a succinct answer. 0.85. What is the ratio of the Value added (constant 2005 US$) in Austria in 2001 to that in 2005?
Provide a short and direct response. 0.92. What is the ratio of the Value added (constant 2005 US$) in Estonia in 2001 to that in 2005?
Your answer should be compact. 0.76. What is the ratio of the Value added (constant 2005 US$) in Serbia in 2001 to that in 2005?
Provide a succinct answer. 0.77. What is the ratio of the Value added (constant 2005 US$) in Central Europe in 2001 to that in 2006?
Provide a short and direct response. 0.81. What is the ratio of the Value added (constant 2005 US$) of Austria in 2001 to that in 2006?
Provide a short and direct response. 0.89. What is the ratio of the Value added (constant 2005 US$) of Estonia in 2001 to that in 2006?
Offer a very short reply. 0.69. What is the ratio of the Value added (constant 2005 US$) of Serbia in 2001 to that in 2006?
Give a very brief answer. 0.73. What is the ratio of the Value added (constant 2005 US$) in Central Europe in 2001 to that in 2007?
Provide a short and direct response. 0.75. What is the ratio of the Value added (constant 2005 US$) of Austria in 2001 to that in 2007?
Your answer should be compact. 0.86. What is the ratio of the Value added (constant 2005 US$) of Estonia in 2001 to that in 2007?
Your answer should be compact. 0.65. What is the ratio of the Value added (constant 2005 US$) in Serbia in 2001 to that in 2007?
Ensure brevity in your answer.  0.68. What is the ratio of the Value added (constant 2005 US$) in Central Europe in 2002 to that in 2003?
Your answer should be very brief. 0.96. What is the ratio of the Value added (constant 2005 US$) of Austria in 2002 to that in 2003?
Make the answer very short. 0.99. What is the ratio of the Value added (constant 2005 US$) of Estonia in 2002 to that in 2003?
Your response must be concise. 0.94. What is the ratio of the Value added (constant 2005 US$) in Serbia in 2002 to that in 2003?
Offer a very short reply. 0.95. What is the ratio of the Value added (constant 2005 US$) of Central Europe in 2002 to that in 2004?
Give a very brief answer. 0.93. What is the ratio of the Value added (constant 2005 US$) of Austria in 2002 to that in 2004?
Keep it short and to the point. 0.97. What is the ratio of the Value added (constant 2005 US$) of Estonia in 2002 to that in 2004?
Your answer should be compact. 0.87. What is the ratio of the Value added (constant 2005 US$) of Serbia in 2002 to that in 2004?
Your answer should be compact. 0.88. What is the ratio of the Value added (constant 2005 US$) of Central Europe in 2002 to that in 2005?
Your answer should be compact. 0.88. What is the ratio of the Value added (constant 2005 US$) in Austria in 2002 to that in 2005?
Offer a terse response. 0.95. What is the ratio of the Value added (constant 2005 US$) of Estonia in 2002 to that in 2005?
Offer a very short reply. 0.8. What is the ratio of the Value added (constant 2005 US$) of Serbia in 2002 to that in 2005?
Your response must be concise. 0.81. What is the ratio of the Value added (constant 2005 US$) in Central Europe in 2002 to that in 2006?
Make the answer very short. 0.84. What is the ratio of the Value added (constant 2005 US$) of Austria in 2002 to that in 2006?
Keep it short and to the point. 0.91. What is the ratio of the Value added (constant 2005 US$) of Estonia in 2002 to that in 2006?
Your answer should be compact. 0.73. What is the ratio of the Value added (constant 2005 US$) of Serbia in 2002 to that in 2006?
Your answer should be compact. 0.77. What is the ratio of the Value added (constant 2005 US$) of Central Europe in 2002 to that in 2007?
Keep it short and to the point. 0.78. What is the ratio of the Value added (constant 2005 US$) of Austria in 2002 to that in 2007?
Your response must be concise. 0.89. What is the ratio of the Value added (constant 2005 US$) of Estonia in 2002 to that in 2007?
Your answer should be compact. 0.68. What is the ratio of the Value added (constant 2005 US$) in Serbia in 2002 to that in 2007?
Make the answer very short. 0.72. What is the ratio of the Value added (constant 2005 US$) of Central Europe in 2003 to that in 2004?
Provide a succinct answer. 0.96. What is the ratio of the Value added (constant 2005 US$) of Austria in 2003 to that in 2004?
Give a very brief answer. 0.97. What is the ratio of the Value added (constant 2005 US$) in Estonia in 2003 to that in 2004?
Provide a succinct answer. 0.93. What is the ratio of the Value added (constant 2005 US$) of Serbia in 2003 to that in 2004?
Ensure brevity in your answer.  0.93. What is the ratio of the Value added (constant 2005 US$) in Central Europe in 2003 to that in 2005?
Offer a very short reply. 0.91. What is the ratio of the Value added (constant 2005 US$) of Austria in 2003 to that in 2005?
Your answer should be very brief. 0.95. What is the ratio of the Value added (constant 2005 US$) in Estonia in 2003 to that in 2005?
Give a very brief answer. 0.86. What is the ratio of the Value added (constant 2005 US$) of Serbia in 2003 to that in 2005?
Provide a succinct answer. 0.85. What is the ratio of the Value added (constant 2005 US$) in Central Europe in 2003 to that in 2006?
Your answer should be compact. 0.87. What is the ratio of the Value added (constant 2005 US$) in Austria in 2003 to that in 2006?
Give a very brief answer. 0.92. What is the ratio of the Value added (constant 2005 US$) in Estonia in 2003 to that in 2006?
Give a very brief answer. 0.78. What is the ratio of the Value added (constant 2005 US$) of Serbia in 2003 to that in 2006?
Keep it short and to the point. 0.81. What is the ratio of the Value added (constant 2005 US$) of Central Europe in 2003 to that in 2007?
Keep it short and to the point. 0.81. What is the ratio of the Value added (constant 2005 US$) of Austria in 2003 to that in 2007?
Provide a succinct answer. 0.89. What is the ratio of the Value added (constant 2005 US$) in Estonia in 2003 to that in 2007?
Provide a succinct answer. 0.73. What is the ratio of the Value added (constant 2005 US$) of Serbia in 2003 to that in 2007?
Make the answer very short. 0.75. What is the ratio of the Value added (constant 2005 US$) of Central Europe in 2004 to that in 2005?
Give a very brief answer. 0.95. What is the ratio of the Value added (constant 2005 US$) of Austria in 2004 to that in 2005?
Provide a succinct answer. 0.98. What is the ratio of the Value added (constant 2005 US$) in Estonia in 2004 to that in 2005?
Keep it short and to the point. 0.92. What is the ratio of the Value added (constant 2005 US$) in Serbia in 2004 to that in 2005?
Offer a terse response. 0.91. What is the ratio of the Value added (constant 2005 US$) of Central Europe in 2004 to that in 2006?
Provide a short and direct response. 0.9. What is the ratio of the Value added (constant 2005 US$) of Austria in 2004 to that in 2006?
Offer a terse response. 0.94. What is the ratio of the Value added (constant 2005 US$) of Estonia in 2004 to that in 2006?
Your response must be concise. 0.83. What is the ratio of the Value added (constant 2005 US$) of Serbia in 2004 to that in 2006?
Your response must be concise. 0.87. What is the ratio of the Value added (constant 2005 US$) of Central Europe in 2004 to that in 2007?
Ensure brevity in your answer.  0.84. What is the ratio of the Value added (constant 2005 US$) of Austria in 2004 to that in 2007?
Give a very brief answer. 0.91. What is the ratio of the Value added (constant 2005 US$) in Estonia in 2004 to that in 2007?
Ensure brevity in your answer.  0.78. What is the ratio of the Value added (constant 2005 US$) of Serbia in 2004 to that in 2007?
Your answer should be compact. 0.81. What is the ratio of the Value added (constant 2005 US$) of Central Europe in 2005 to that in 2006?
Keep it short and to the point. 0.95. What is the ratio of the Value added (constant 2005 US$) in Austria in 2005 to that in 2006?
Give a very brief answer. 0.96. What is the ratio of the Value added (constant 2005 US$) of Estonia in 2005 to that in 2006?
Your answer should be very brief. 0.91. What is the ratio of the Value added (constant 2005 US$) in Serbia in 2005 to that in 2006?
Provide a short and direct response. 0.95. What is the ratio of the Value added (constant 2005 US$) of Central Europe in 2005 to that in 2007?
Offer a terse response. 0.89. What is the ratio of the Value added (constant 2005 US$) in Austria in 2005 to that in 2007?
Offer a terse response. 0.94. What is the ratio of the Value added (constant 2005 US$) in Estonia in 2005 to that in 2007?
Provide a succinct answer. 0.85. What is the ratio of the Value added (constant 2005 US$) of Serbia in 2005 to that in 2007?
Give a very brief answer. 0.89. What is the ratio of the Value added (constant 2005 US$) in Central Europe in 2006 to that in 2007?
Keep it short and to the point. 0.93. What is the ratio of the Value added (constant 2005 US$) in Austria in 2006 to that in 2007?
Provide a short and direct response. 0.97. What is the ratio of the Value added (constant 2005 US$) of Estonia in 2006 to that in 2007?
Offer a very short reply. 0.93. What is the ratio of the Value added (constant 2005 US$) in Serbia in 2006 to that in 2007?
Make the answer very short. 0.93. What is the difference between the highest and the second highest Value added (constant 2005 US$) of Central Europe?
Offer a very short reply. 3.70e+1. What is the difference between the highest and the second highest Value added (constant 2005 US$) of Austria?
Make the answer very short. 5.94e+09. What is the difference between the highest and the second highest Value added (constant 2005 US$) of Estonia?
Provide a short and direct response. 6.43e+08. What is the difference between the highest and the second highest Value added (constant 2005 US$) in Serbia?
Keep it short and to the point. 1.02e+09. What is the difference between the highest and the lowest Value added (constant 2005 US$) in Central Europe?
Give a very brief answer. 1.38e+11. What is the difference between the highest and the lowest Value added (constant 2005 US$) in Austria?
Offer a terse response. 2.78e+1. What is the difference between the highest and the lowest Value added (constant 2005 US$) of Estonia?
Offer a very short reply. 3.46e+09. What is the difference between the highest and the lowest Value added (constant 2005 US$) in Serbia?
Provide a succinct answer. 4.68e+09. 